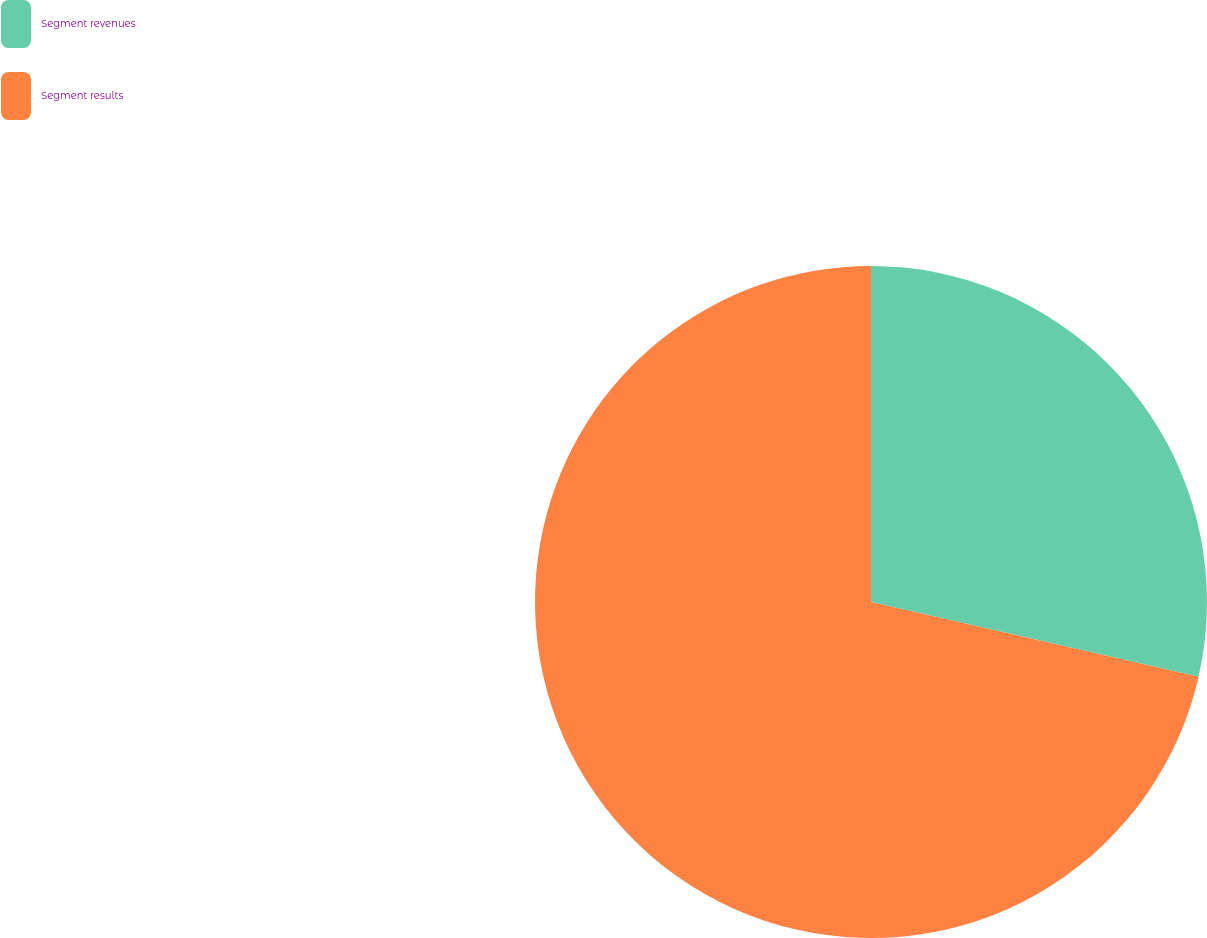Convert chart. <chart><loc_0><loc_0><loc_500><loc_500><pie_chart><fcel>Segment revenues<fcel>Segment results<nl><fcel>28.57%<fcel>71.43%<nl></chart> 